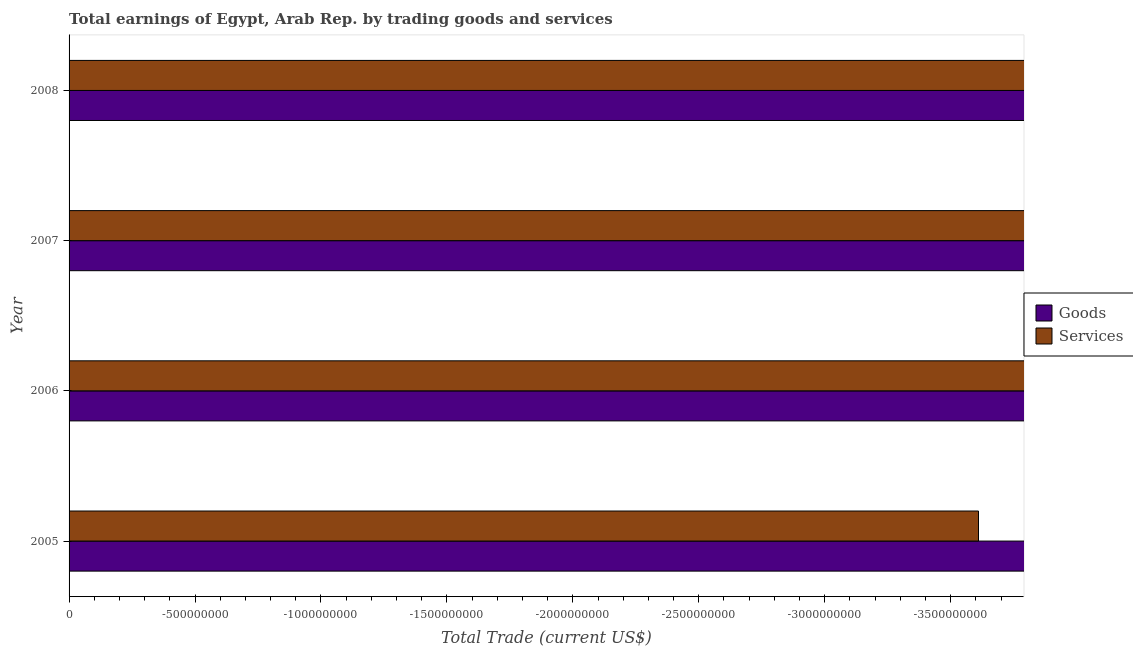Are the number of bars on each tick of the Y-axis equal?
Give a very brief answer. Yes. How many bars are there on the 1st tick from the top?
Give a very brief answer. 0. What is the label of the 2nd group of bars from the top?
Offer a very short reply. 2007. Across all years, what is the minimum amount earned by trading goods?
Offer a very short reply. 0. What is the total amount earned by trading goods in the graph?
Your answer should be compact. 0. What is the average amount earned by trading goods per year?
Offer a terse response. 0. In how many years, is the amount earned by trading services greater than -2500000000 US$?
Your answer should be compact. 0. Are all the bars in the graph horizontal?
Provide a short and direct response. Yes. Does the graph contain any zero values?
Offer a very short reply. Yes. Does the graph contain grids?
Your response must be concise. No. What is the title of the graph?
Provide a short and direct response. Total earnings of Egypt, Arab Rep. by trading goods and services. Does "Secondary Education" appear as one of the legend labels in the graph?
Ensure brevity in your answer.  No. What is the label or title of the X-axis?
Make the answer very short. Total Trade (current US$). What is the label or title of the Y-axis?
Keep it short and to the point. Year. What is the Total Trade (current US$) in Goods in 2006?
Ensure brevity in your answer.  0. What is the Total Trade (current US$) of Goods in 2007?
Offer a very short reply. 0. What is the Total Trade (current US$) of Services in 2007?
Your answer should be compact. 0. What is the Total Trade (current US$) in Goods in 2008?
Your response must be concise. 0. What is the Total Trade (current US$) in Services in 2008?
Offer a terse response. 0. What is the total Total Trade (current US$) in Services in the graph?
Give a very brief answer. 0. What is the average Total Trade (current US$) of Goods per year?
Ensure brevity in your answer.  0. 